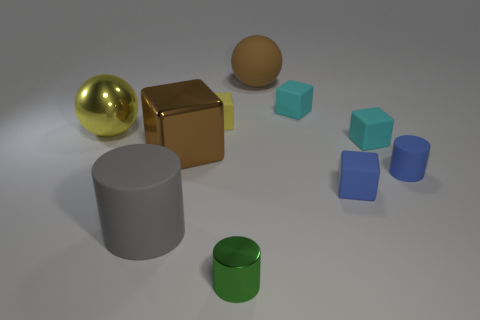There is a matte thing that is the same color as the metal block; what is its size?
Keep it short and to the point. Large. Is there a tiny yellow thing that has the same material as the large gray thing?
Your answer should be compact. Yes. What is the material of the large ball that is on the right side of the gray thing?
Provide a short and direct response. Rubber. Is the color of the metal object left of the gray rubber object the same as the tiny matte block that is to the left of the brown sphere?
Your answer should be very brief. Yes. What color is the matte cylinder that is the same size as the green object?
Ensure brevity in your answer.  Blue. How many other things are the same shape as the small yellow thing?
Make the answer very short. 4. What is the size of the cyan thing that is in front of the yellow matte block?
Offer a very short reply. Small. How many small blue things are in front of the large gray cylinder on the left side of the brown cube?
Ensure brevity in your answer.  0. How many other things are the same size as the yellow rubber object?
Your answer should be compact. 5. Is the large block the same color as the big rubber sphere?
Offer a very short reply. Yes. 